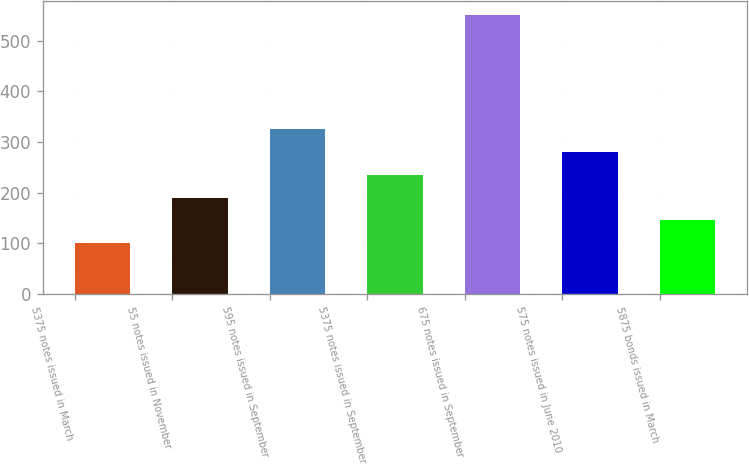Convert chart. <chart><loc_0><loc_0><loc_500><loc_500><bar_chart><fcel>5375 notes issued in March<fcel>55 notes issued in November<fcel>595 notes issued in September<fcel>5375 notes issued in September<fcel>675 notes issued in September<fcel>575 notes issued in June 2010<fcel>5875 bonds issued in March<nl><fcel>100<fcel>190<fcel>325<fcel>235<fcel>550<fcel>280<fcel>145<nl></chart> 